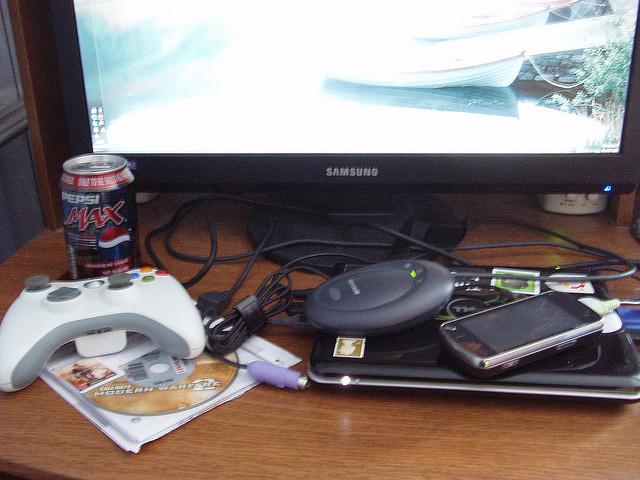What gaming system is the controller for?
Keep it brief. X-box. What kind of soda is on the desk?
Give a very brief answer. Pepsi max. Is there an iPhone on the table?
Quick response, please. No. 